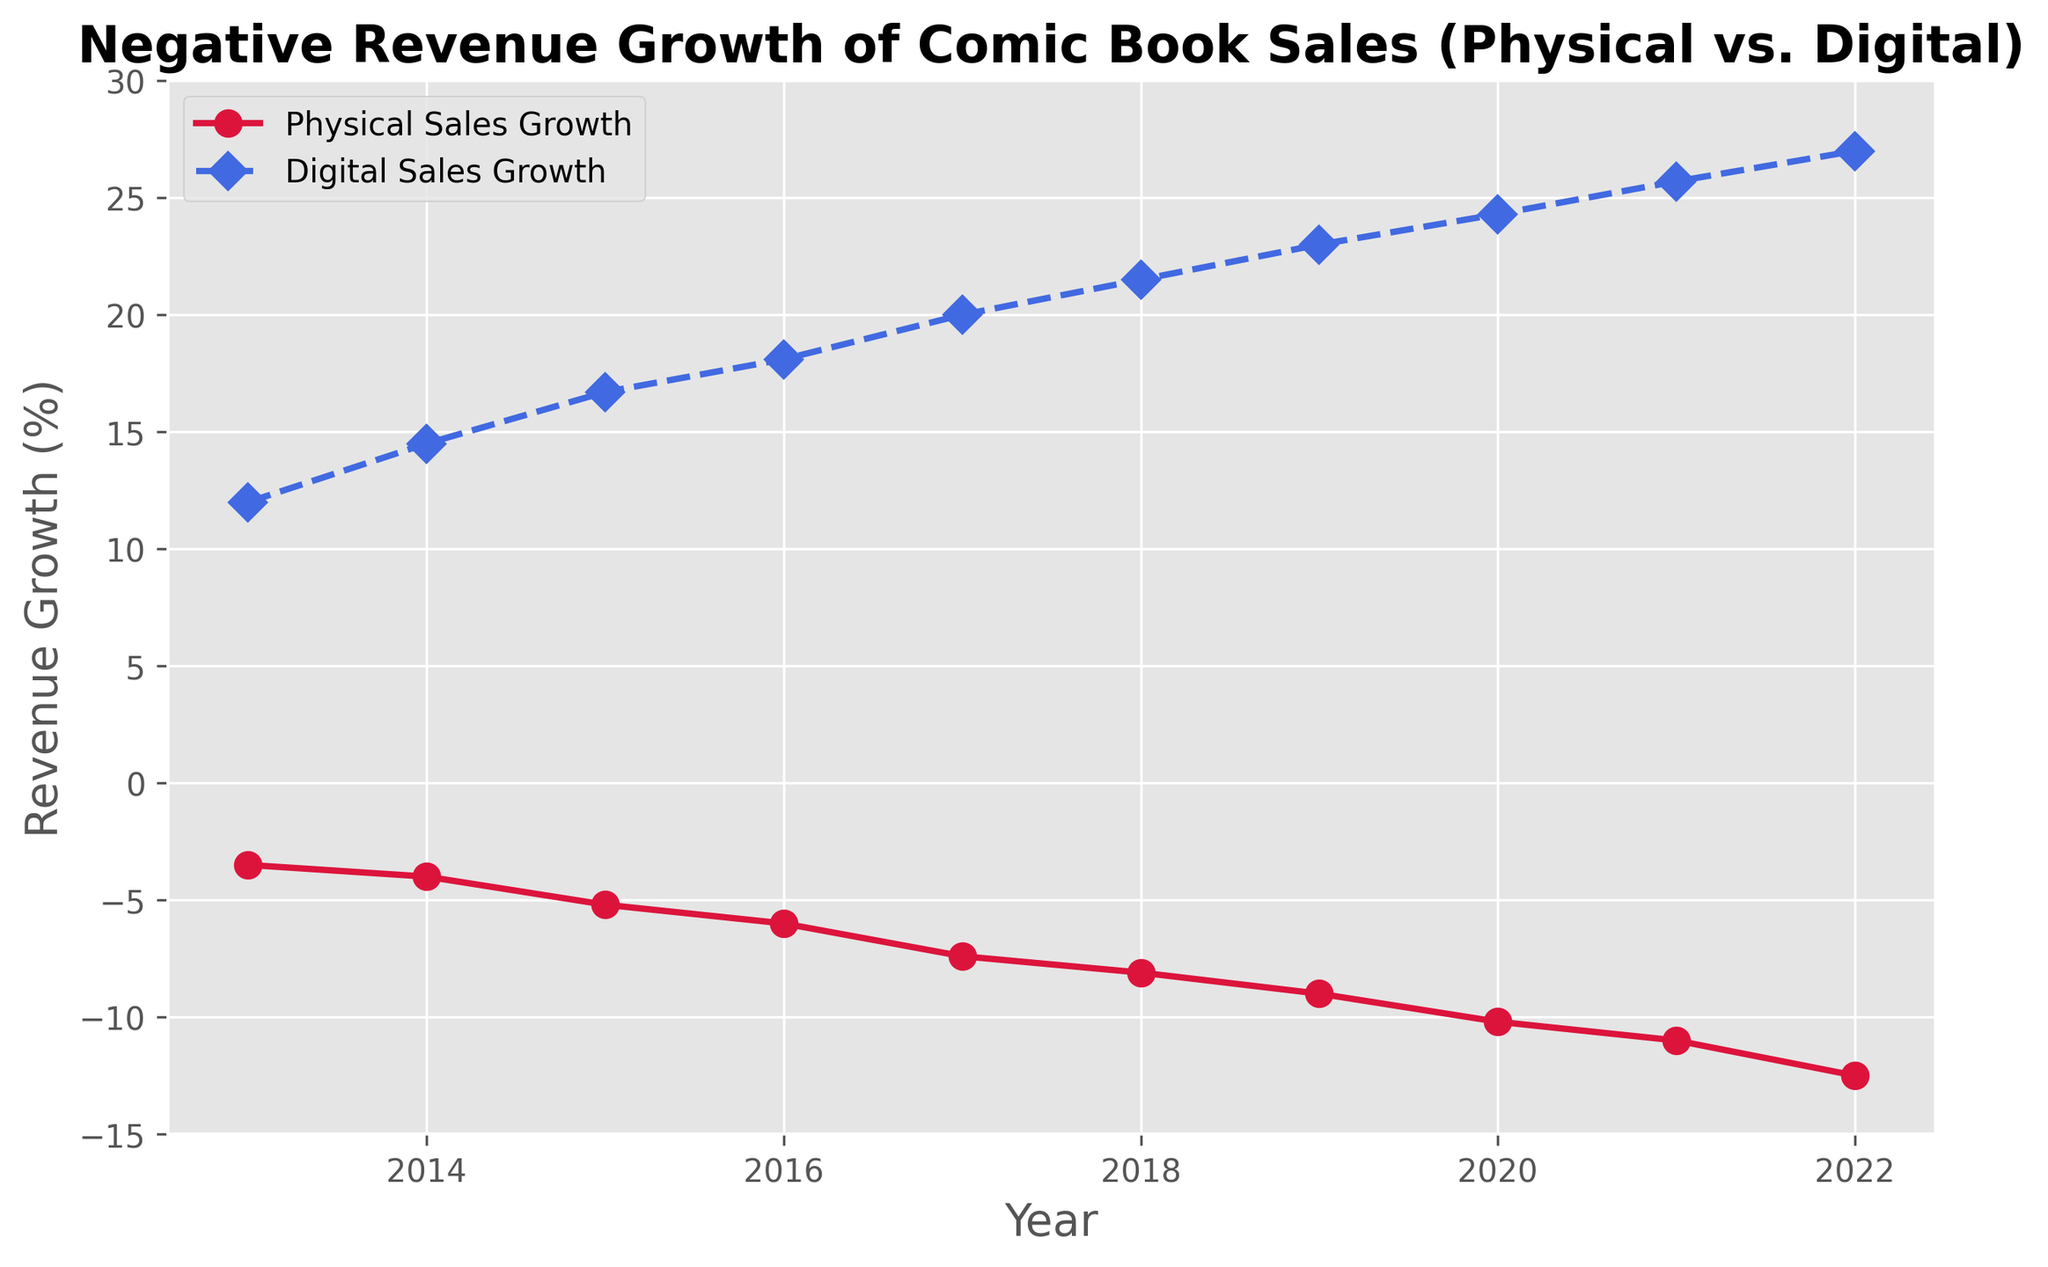What year had the most significant negative growth in physical comic book sales? The most significant negative growth in physical comic book sales can be identified by finding the year with the lowest point on the red line. From the plot, the year 2022 shows the largest negative growth at -12.5%.
Answer: 2022 How does the trend of physical comic book sales growth compare to digital comic book sales growth overall? By observing the lines, the physical comic book sales growth (red line) consistently decreases each year, whereas the digital comic book sales growth (blue line) increases. This demonstrates an inverse relationship: as physical sales decline, digital sales grow.
Answer: Inverse relationship What was the difference in revenue growth between physical and digital comic book sales in 2017? The physical comic book sales growth in 2017 was -7.4%, and the digital comic book sales growth was 20.0%. The difference is calculated by subtracting the physical growth from the digital growth: 20.0% - (-7.4%) = 27.4%.
Answer: 27.4% In which year did digital comic book sales growth surpass 20%? From the plot, the year when the digital comic book sales growth first exceeded 20% is 2017, with a growth rate of 20.0%.
Answer: 2017 What was the average growth rate of digital comic book sales between 2013 and 2016? To find the average growth rate, sum the digital growth rates from 2013 to 2016 and divide by the number of years: (12.0 + 14.5 + 16.7 + 18.1) / 4 = 15.825%.
Answer: 15.825% Which segment (physical or digital) shows a steeper slope in their growth trend over the decade? The steeper slope indicates a more significant change over time. Visually, the blue line representing digital sales growth shows a steeper upward trend compared to the red line's downward trend, indicating faster growth.
Answer: Digital By how much did the physical comic book sales growth rate change from 2013 to 2022? The physical comic book sales growth rate in 2013 was -3.5%, and in 2022 it was -12.5%. The change can be calculated as: -3.5% - (-12.5%) = 9.0%.
Answer: 9.0% In which year did the smallest decline in physical comic book sales growth occur? The smallest decline can be found by identifying the highest value on the red line, which in this case is the year 2013 with a growth rate of -3.5%.
Answer: 2013 